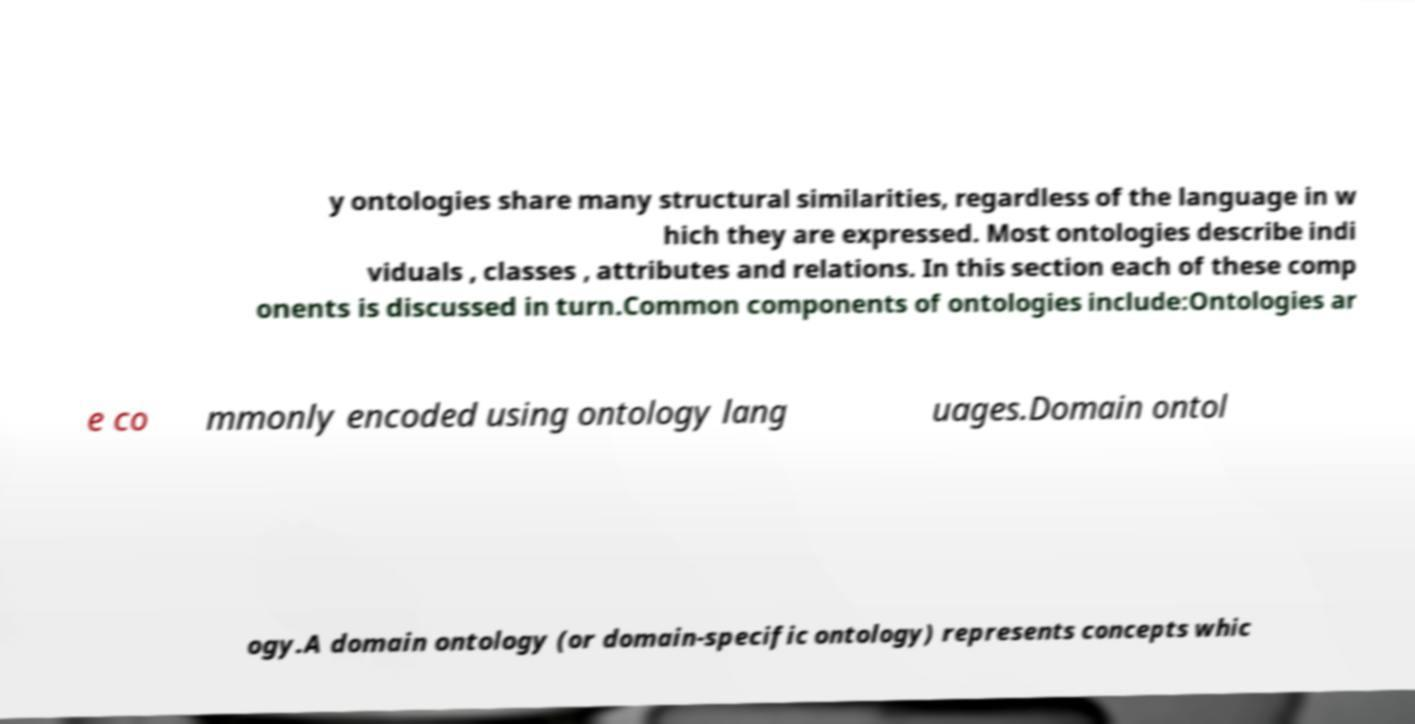What messages or text are displayed in this image? I need them in a readable, typed format. y ontologies share many structural similarities, regardless of the language in w hich they are expressed. Most ontologies describe indi viduals , classes , attributes and relations. In this section each of these comp onents is discussed in turn.Common components of ontologies include:Ontologies ar e co mmonly encoded using ontology lang uages.Domain ontol ogy.A domain ontology (or domain-specific ontology) represents concepts whic 